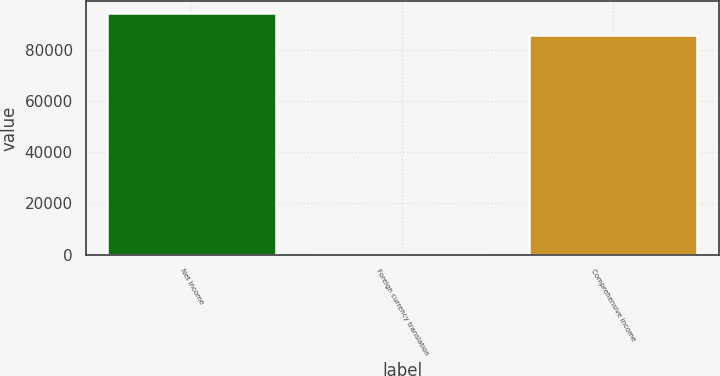<chart> <loc_0><loc_0><loc_500><loc_500><bar_chart><fcel>Net income<fcel>Foreign currency translation<fcel>Comprehensive income<nl><fcel>94223.8<fcel>11<fcel>85658<nl></chart> 